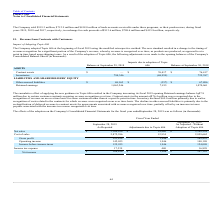According to Plexus's financial document, What was the amount of Net Sales as reported? According to the financial document, 3,164,434 (in thousands). The relevant text states: "Net sales $ 3,164,434 $ 14,880 $ 3,149,554..." Also, What was the cost of sales adjustments due to Topic 606? According to the financial document, 12,934 (in thousands). The relevant text states: "Cost of sales 2,872,596 12,934 2,859,662..." Also, What was the Gross Profit after adjustment? According to the financial document, 289,892 (in thousands). The relevant text states: "Gross profit 291,838 1,946 289,892..." Also, How many types of revenues had adjustments that exceeded $10,000 thousand? Counting the relevant items in the document: Net sales, cost of sales, I find 2 instances. The key data points involved are: Net sales, cost of sales. Also, can you calculate: What was the difference in the amount as reported between Operating income and income before income taxes? Based on the calculation: 142,055-125,955, the result is 16100 (in thousands). This is based on the information: "Operating income 142,055 1,946 140,109 Income before income taxes 125,955 1,946 124,009..." The key data points involved are: 125,955, 142,055. Also, can you calculate: What was the percentage change in the net income before and after adjustments? To answer this question, I need to perform calculations using the financial data. The calculation is: (107,110-108,616)/108,616, which equals -1.39 (percentage). This is based on the information: "Net income $ 108,616 $ 1,506 $ 107,110 Net income $ 108,616 $ 1,506 $ 107,110..." The key data points involved are: 107,110, 108,616. 